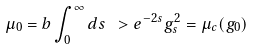Convert formula to latex. <formula><loc_0><loc_0><loc_500><loc_500>\mu _ { 0 } = b \int _ { 0 } ^ { \infty } d s \ > e ^ { - 2 s } g _ { s } ^ { 2 } = \mu _ { c } ( g _ { 0 } )</formula> 